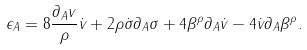<formula> <loc_0><loc_0><loc_500><loc_500>\epsilon _ { A } = 8 \frac { \partial _ { A } v } { \rho } \dot { v } + 2 \rho \dot { \sigma } \partial _ { A } \sigma + 4 \beta ^ { \rho } \partial _ { A } \dot { v } - 4 \dot { v } \partial _ { A } \beta ^ { \rho } .</formula> 